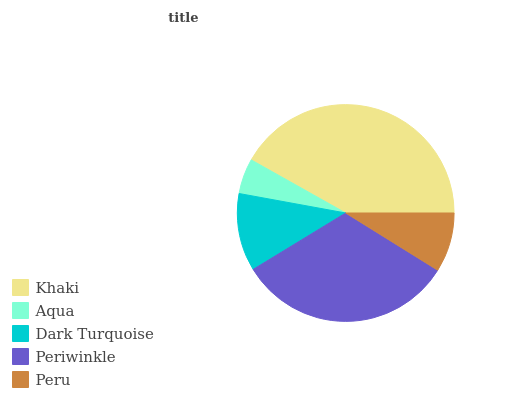Is Aqua the minimum?
Answer yes or no. Yes. Is Khaki the maximum?
Answer yes or no. Yes. Is Dark Turquoise the minimum?
Answer yes or no. No. Is Dark Turquoise the maximum?
Answer yes or no. No. Is Dark Turquoise greater than Aqua?
Answer yes or no. Yes. Is Aqua less than Dark Turquoise?
Answer yes or no. Yes. Is Aqua greater than Dark Turquoise?
Answer yes or no. No. Is Dark Turquoise less than Aqua?
Answer yes or no. No. Is Dark Turquoise the high median?
Answer yes or no. Yes. Is Dark Turquoise the low median?
Answer yes or no. Yes. Is Khaki the high median?
Answer yes or no. No. Is Periwinkle the low median?
Answer yes or no. No. 